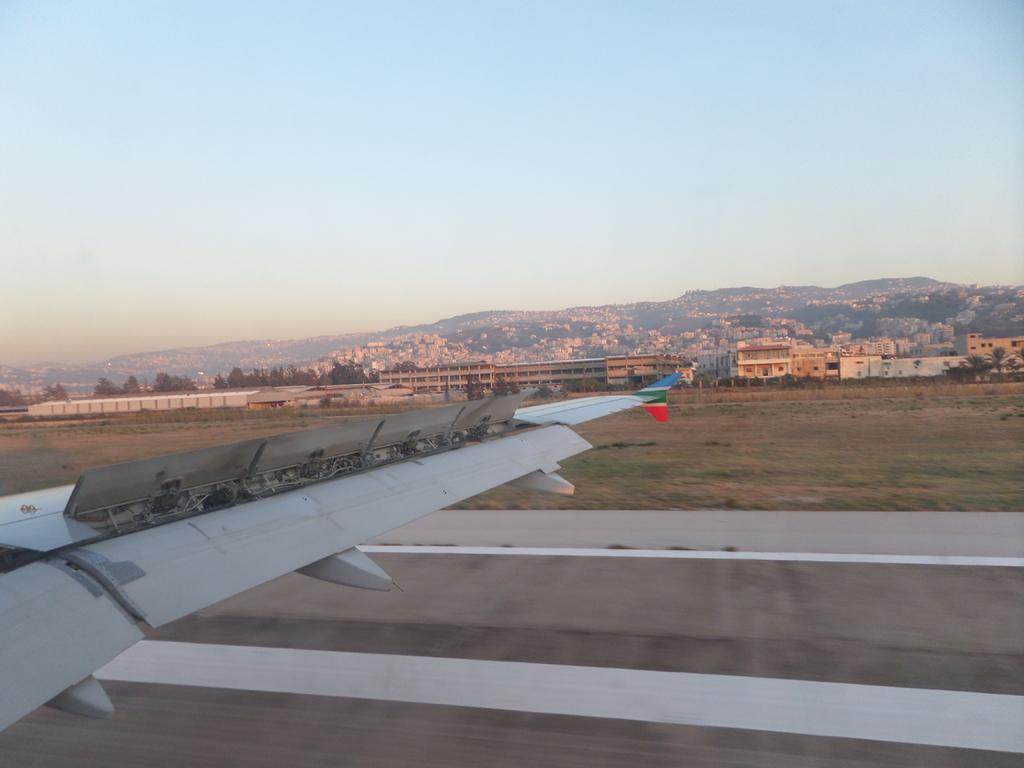What is the main feature of the image? There is a road in the image. image. What can be seen on the left side of the image? There is a part of an aircraft on the left side of the image. What is visible in the background of the image? There are trees and the sky visible in the background of the image. What type of nail is being used to hold the trees in place? There is no nail present in the image, and the trees are not being held in place. 